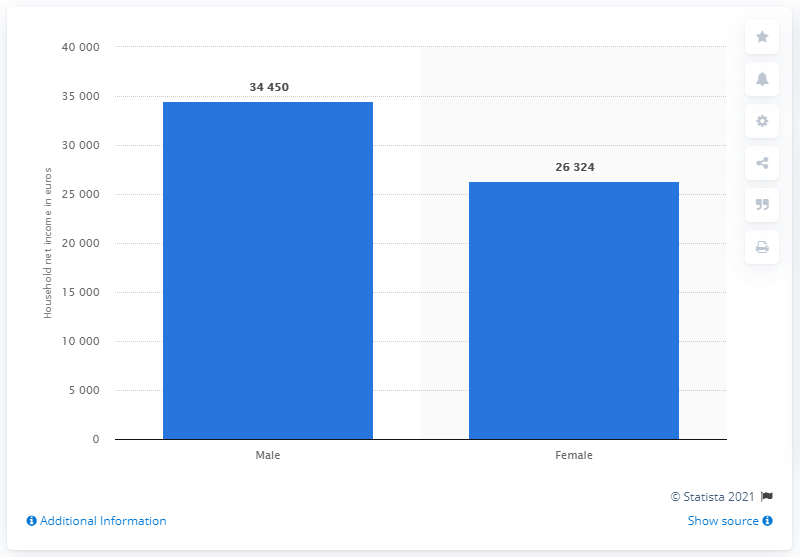Specify some key components in this picture. In 2017, the average household net income in Italy was approximately 34,450 euros. It is estimated that the average net income for women in Italy in 2017 was approximately 26,324 euros. 